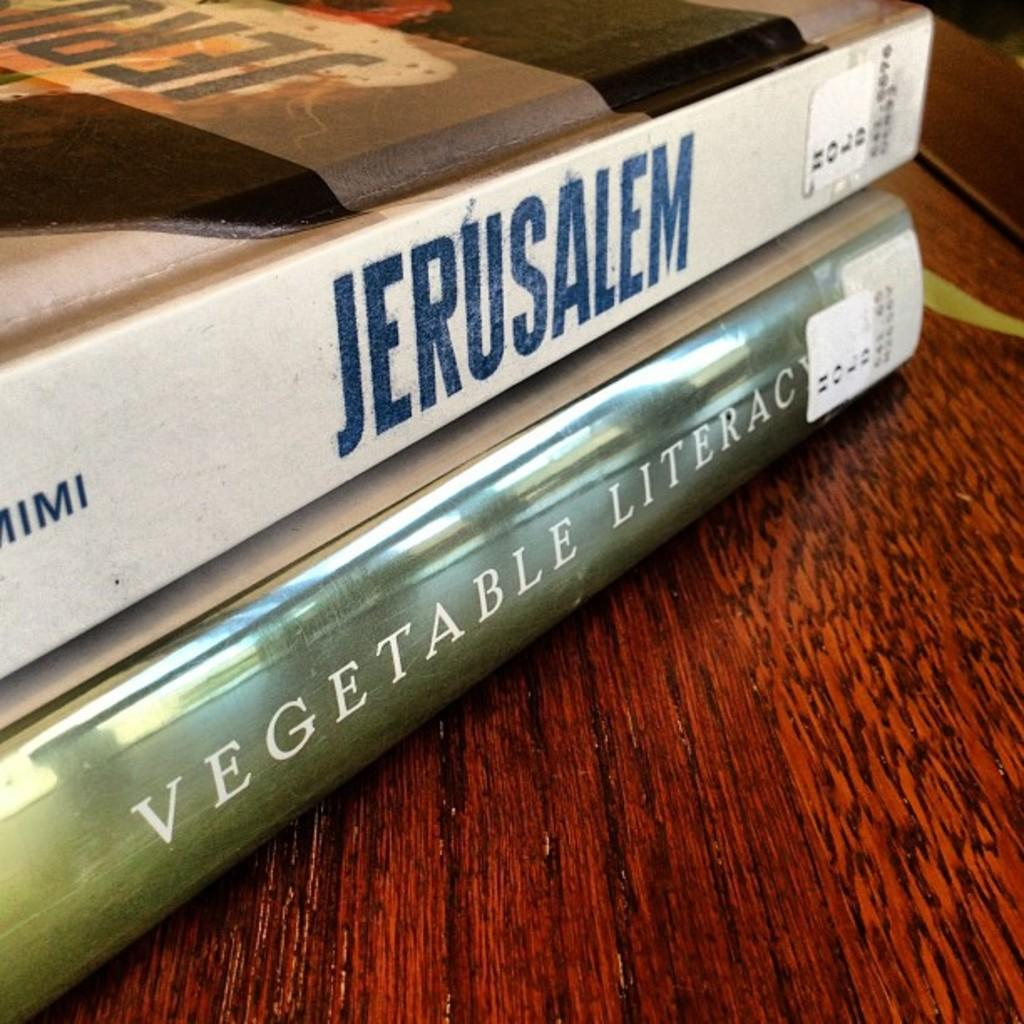<image>
Write a terse but informative summary of the picture. A copy of Jerusalem sits on top of a copy of Vegetable Literacy. 